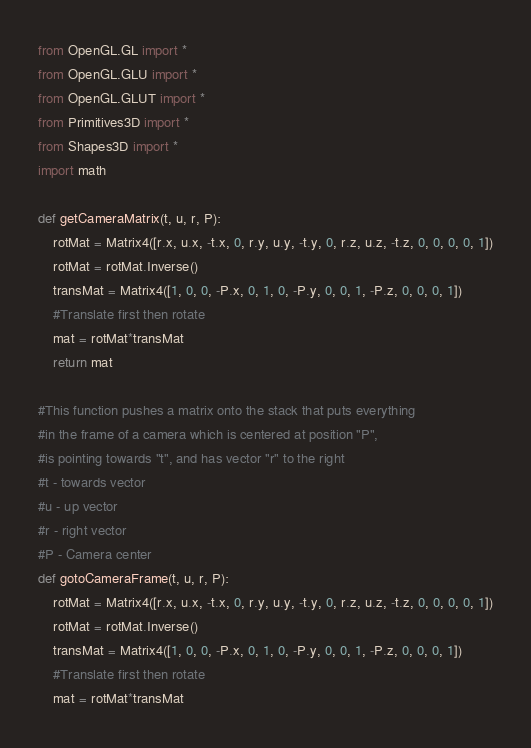<code> <loc_0><loc_0><loc_500><loc_500><_Python_>from OpenGL.GL import *
from OpenGL.GLU import *
from OpenGL.GLUT import *
from Primitives3D import *
from Shapes3D import *
import math

def getCameraMatrix(t, u, r, P):
	rotMat = Matrix4([r.x, u.x, -t.x, 0, r.y, u.y, -t.y, 0, r.z, u.z, -t.z, 0, 0, 0, 0, 1])
	rotMat = rotMat.Inverse()
	transMat = Matrix4([1, 0, 0, -P.x, 0, 1, 0, -P.y, 0, 0, 1, -P.z, 0, 0, 0, 1])
	#Translate first then rotate
	mat = rotMat*transMat
	return mat

#This function pushes a matrix onto the stack that puts everything
#in the frame of a camera which is centered at position "P",
#is pointing towards "t", and has vector "r" to the right
#t - towards vector
#u - up vector
#r - right vector
#P - Camera center
def gotoCameraFrame(t, u, r, P):
	rotMat = Matrix4([r.x, u.x, -t.x, 0, r.y, u.y, -t.y, 0, r.z, u.z, -t.z, 0, 0, 0, 0, 1])
	rotMat = rotMat.Inverse()
	transMat = Matrix4([1, 0, 0, -P.x, 0, 1, 0, -P.y, 0, 0, 1, -P.z, 0, 0, 0, 1])
	#Translate first then rotate
	mat = rotMat*transMat</code> 